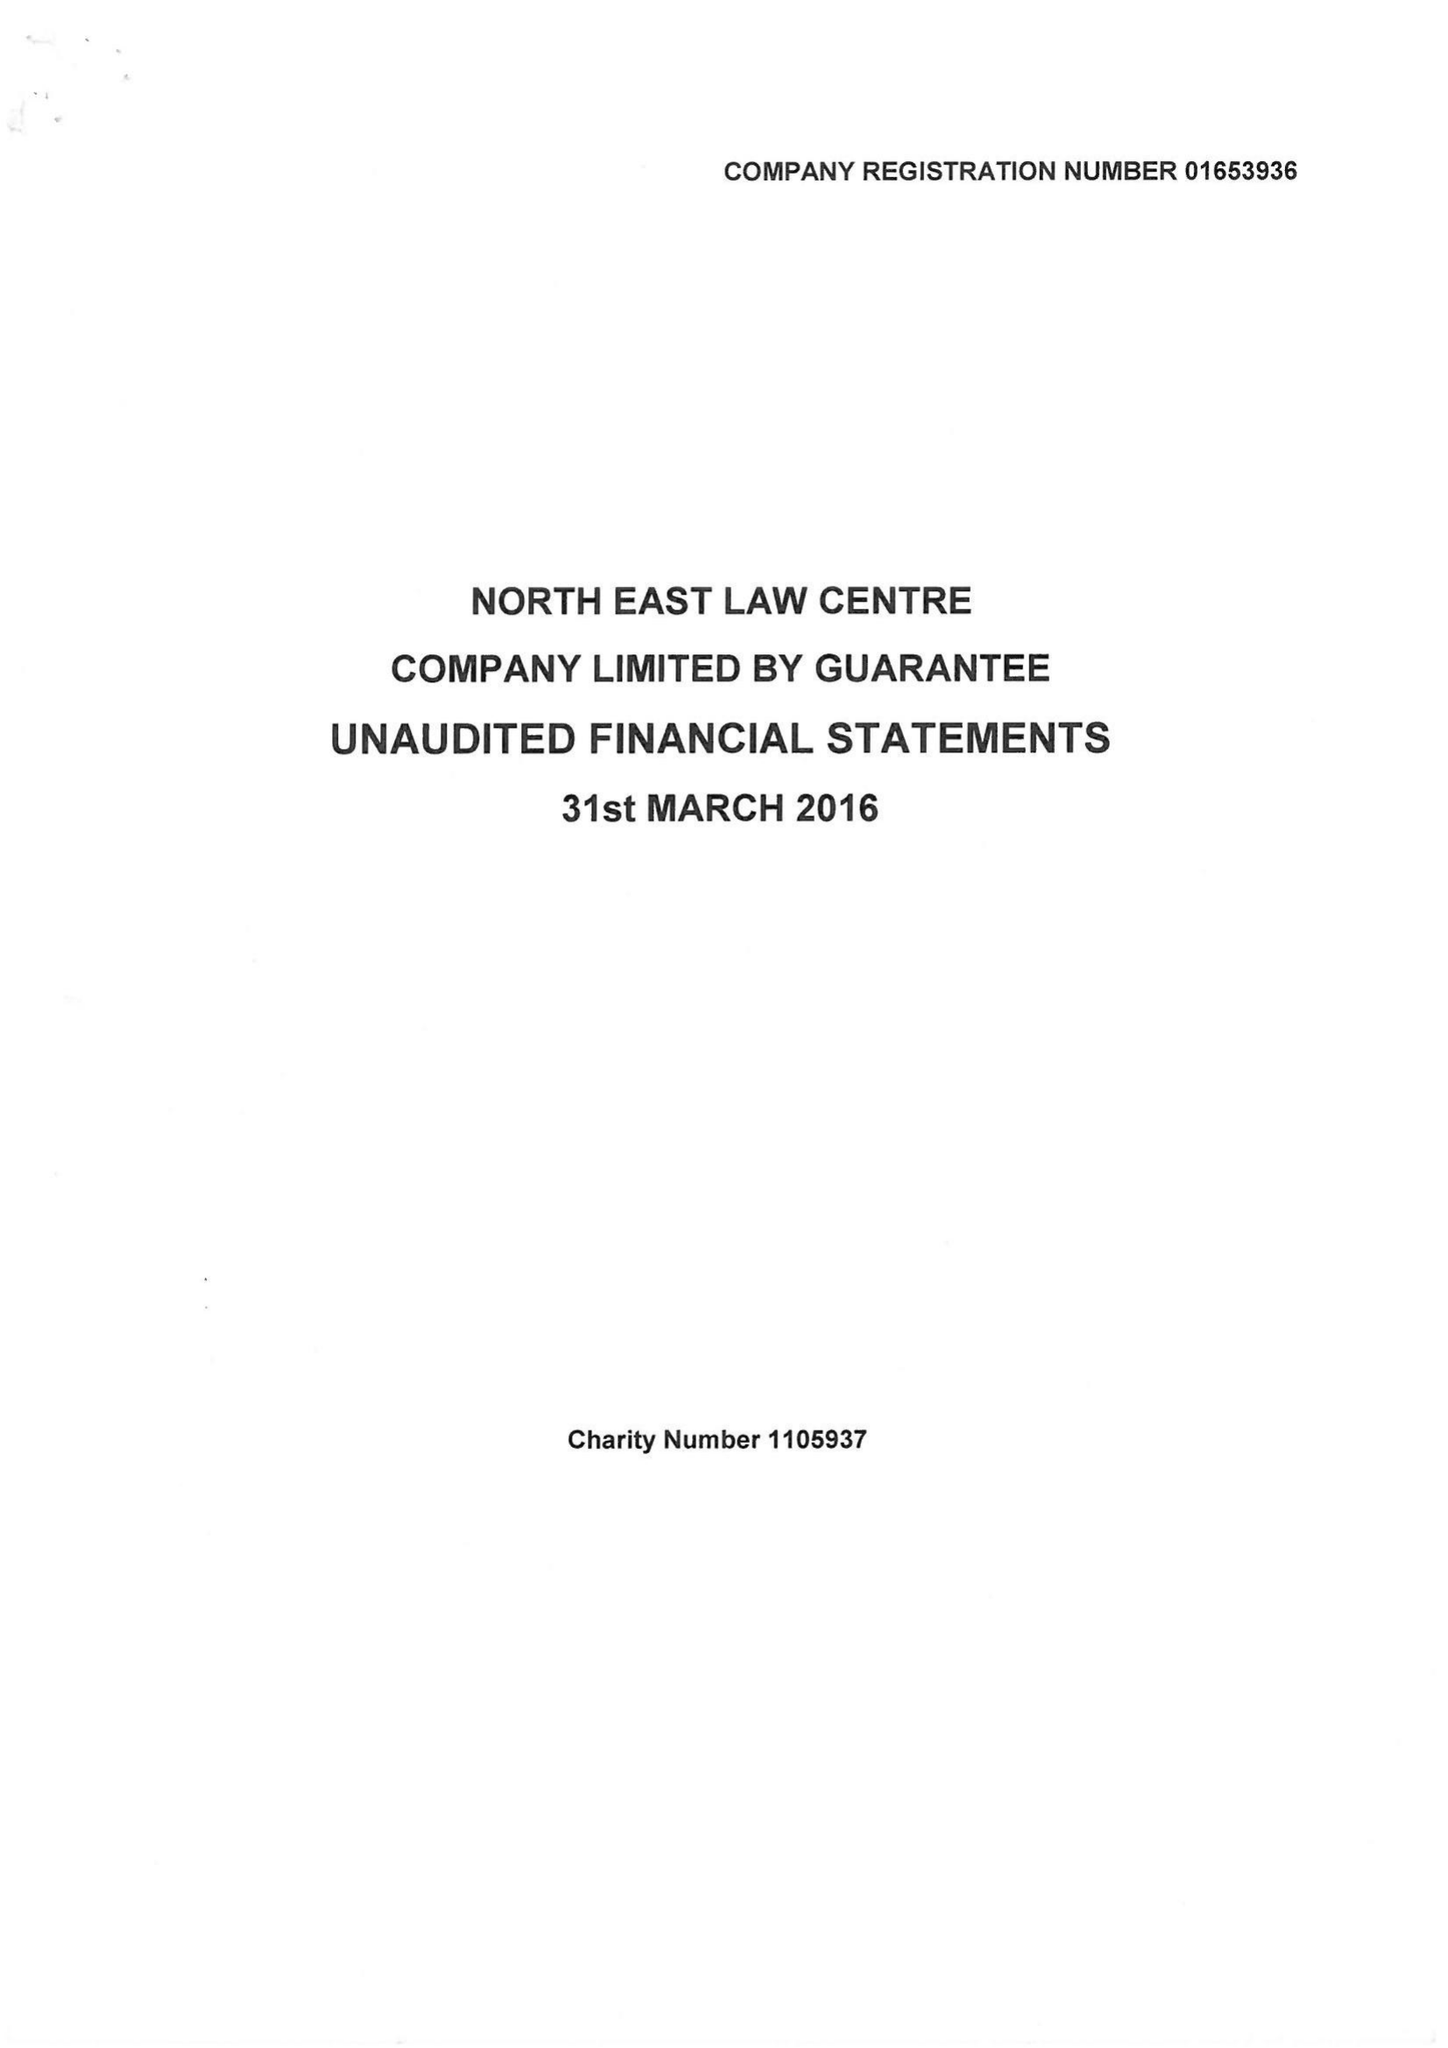What is the value for the address__post_town?
Answer the question using a single word or phrase. NEWCASTLE UPON TYNE 